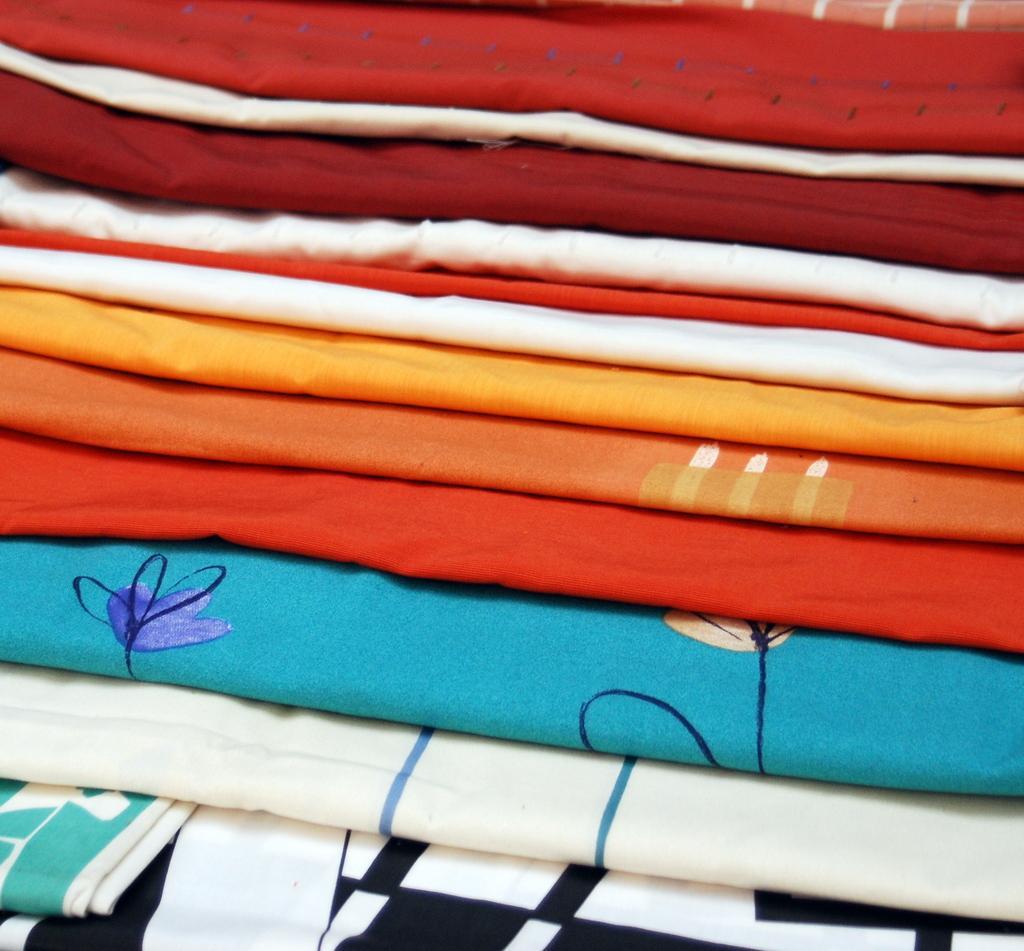Describe this image in one or two sentences. In this picture we can see colorful blue, orange, red and white bed sheet clothes seen in the middle of the image. 